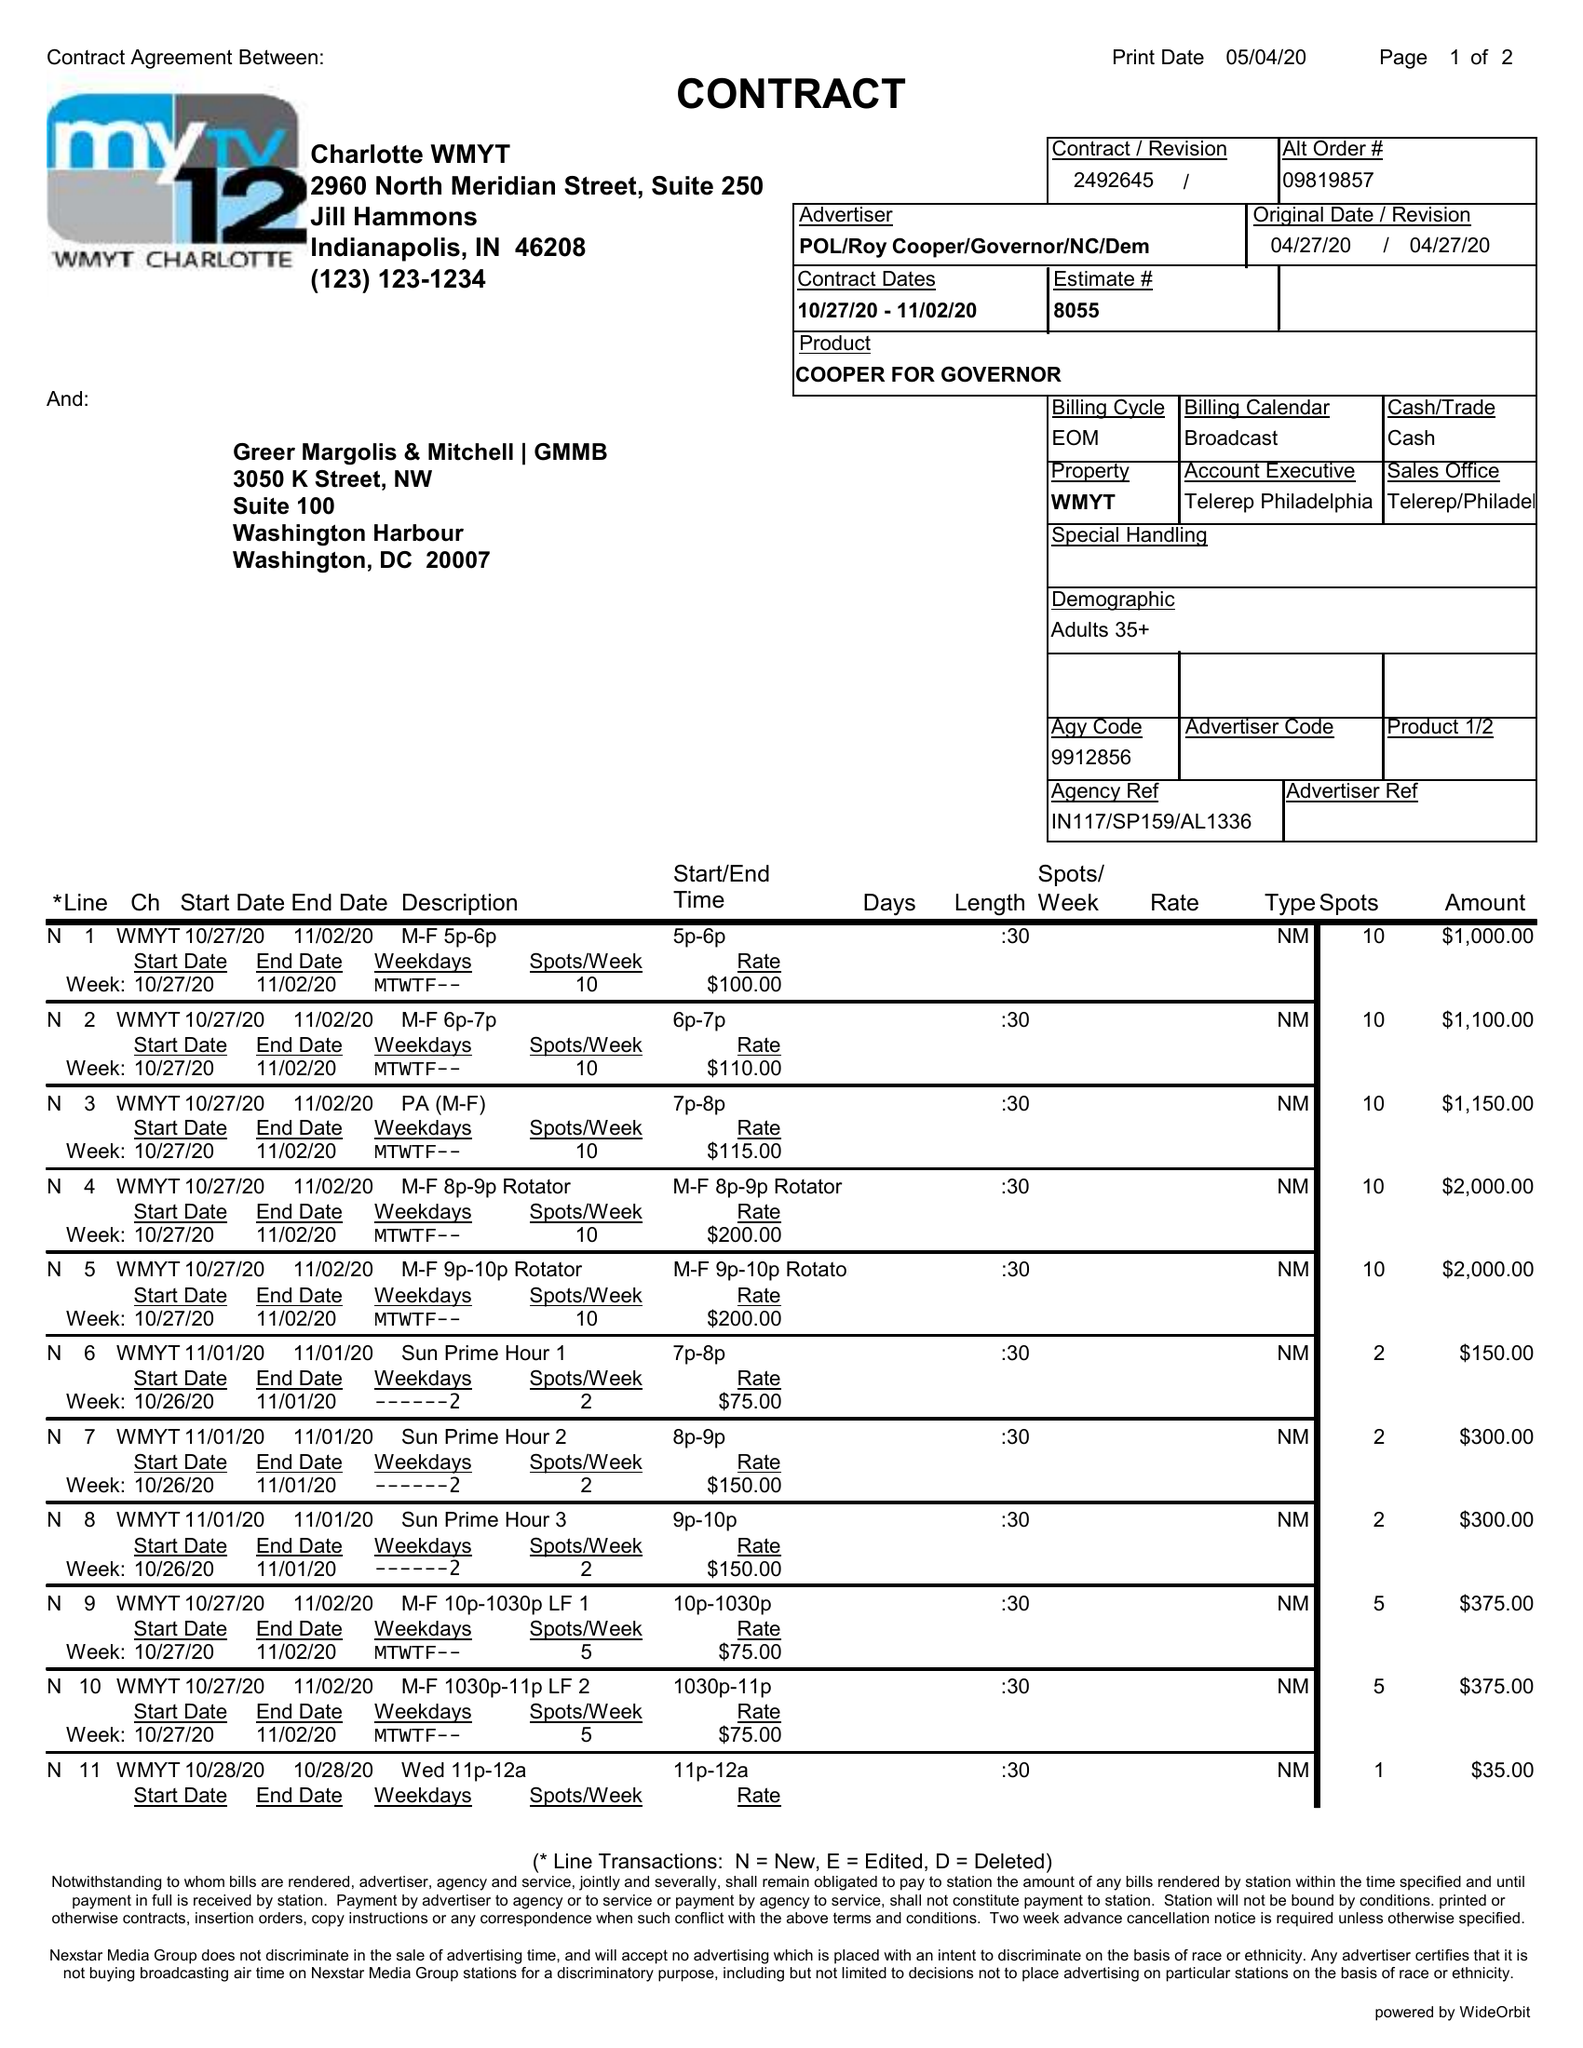What is the value for the flight_from?
Answer the question using a single word or phrase. 10/27/20 